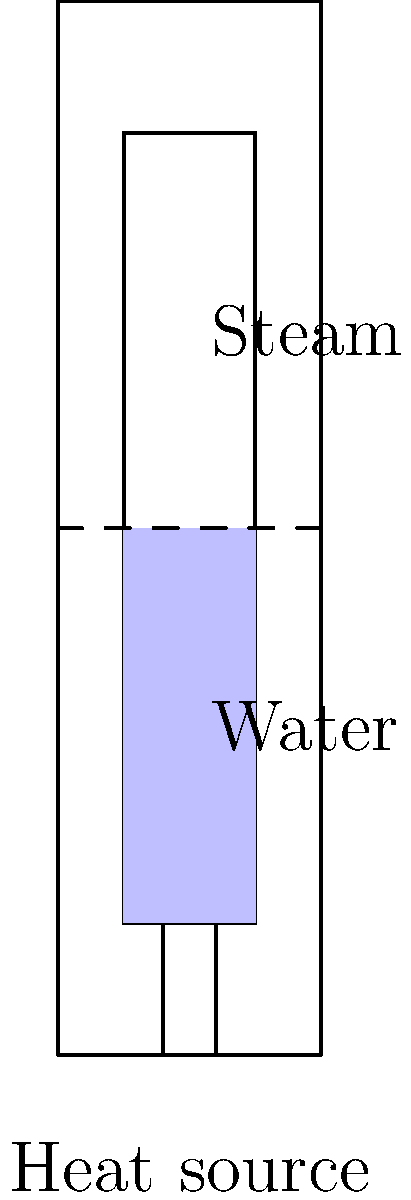A traditional Russian samovar, used for heating water for tea, operates on principles of fluid dynamics. The samovar shown in the cutaway view has an inner chamber with a height of 60 cm and a diameter of 10 cm. If the water level is at 30 cm and the heat source maintains the water at its boiling point (100°C), calculate the volume flow rate of steam (in m³/s) exiting the top of the samovar. Assume the steam behaves as an ideal gas and exits at atmospheric pressure (101.325 kPa) and 100°C. The specific gas constant for water vapor is $R = 461.5 \,\text{J/(kg·K)}$. To solve this problem, we'll follow these steps:

1) First, we need to calculate the mass flow rate of steam. This can be done using the rate of heat transfer to vaporize the water.

2) The heat of vaporization of water at 100°C is $2257 \,\text{kJ/kg}$. Let's assume the heat source provides 1 kW of power to vaporize the water.

3) Mass flow rate of steam:
   $$\dot{m} = \frac{Q}{\Delta H_{\text{vap}}} = \frac{1 \,\text{kW}}{2257 \,\text{kJ/kg}} = 4.43 \times 10^{-4} \,\text{kg/s}$$

4) Now, we can use the ideal gas law to find the volume flow rate:
   $$PV = mRT$$

5) Rearranging for volume and dividing both sides by time:
   $$\frac{V}{t} = \frac{\dot{m}RT}{P}$$

6) Substituting the values:
   $$\dot{V} = \frac{(4.43 \times 10^{-4} \,\text{kg/s})(461.5 \,\text{J/(kg·K)})(373.15 \,\text{K})}{101325 \,\text{Pa}}$$

7) Calculating:
   $$\dot{V} = 7.51 \times 10^{-4} \,\text{m³/s}$$

Thus, the volume flow rate of steam exiting the samovar is approximately $7.51 \times 10^{-4} \,\text{m³/s}$.
Answer: $7.51 \times 10^{-4} \,\text{m³/s}$ 